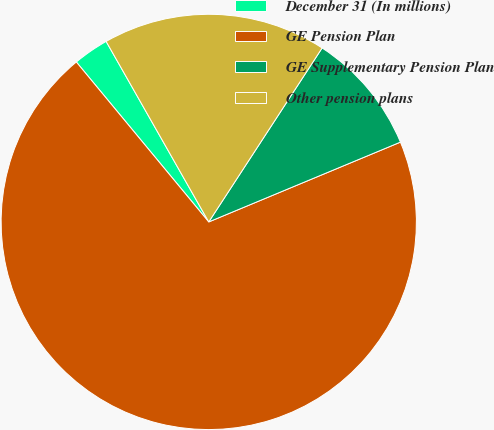Convert chart. <chart><loc_0><loc_0><loc_500><loc_500><pie_chart><fcel>December 31 (In millions)<fcel>GE Pension Plan<fcel>GE Supplementary Pension Plan<fcel>Other pension plans<nl><fcel>2.78%<fcel>70.28%<fcel>9.53%<fcel>17.42%<nl></chart> 